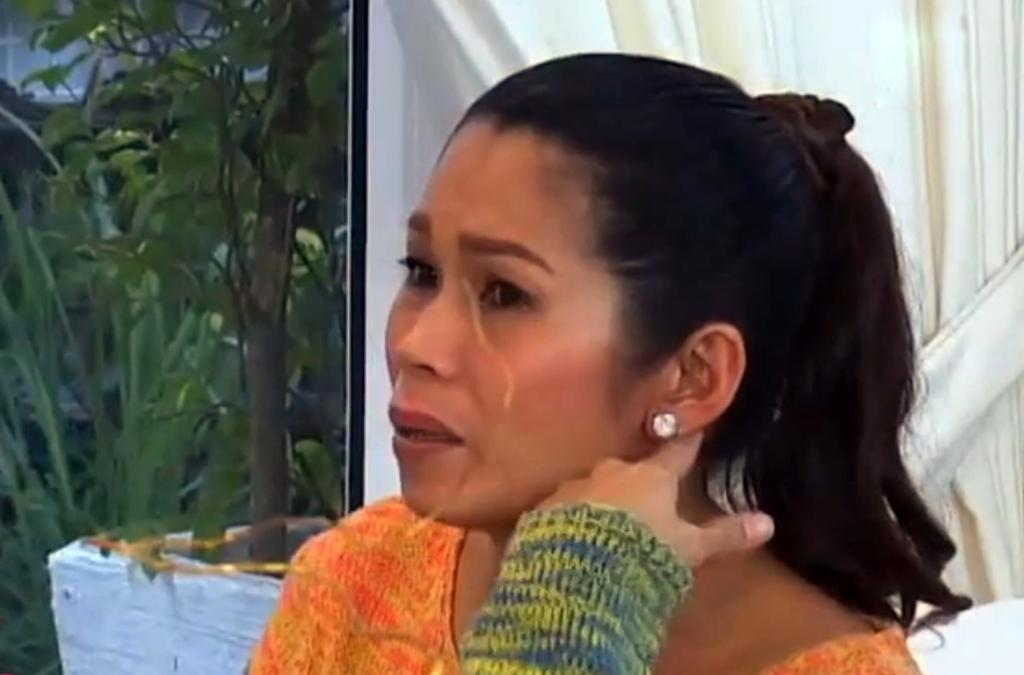Who is the main subject in the image? There is a woman in the image. What is the woman wearing? The woman is wearing an orange dress. What can be seen in the left corner of the image? There are plants in the left corner of the image. What is the value of the dog in the image? There is no dog present in the image, so it is not possible to determine its value. 